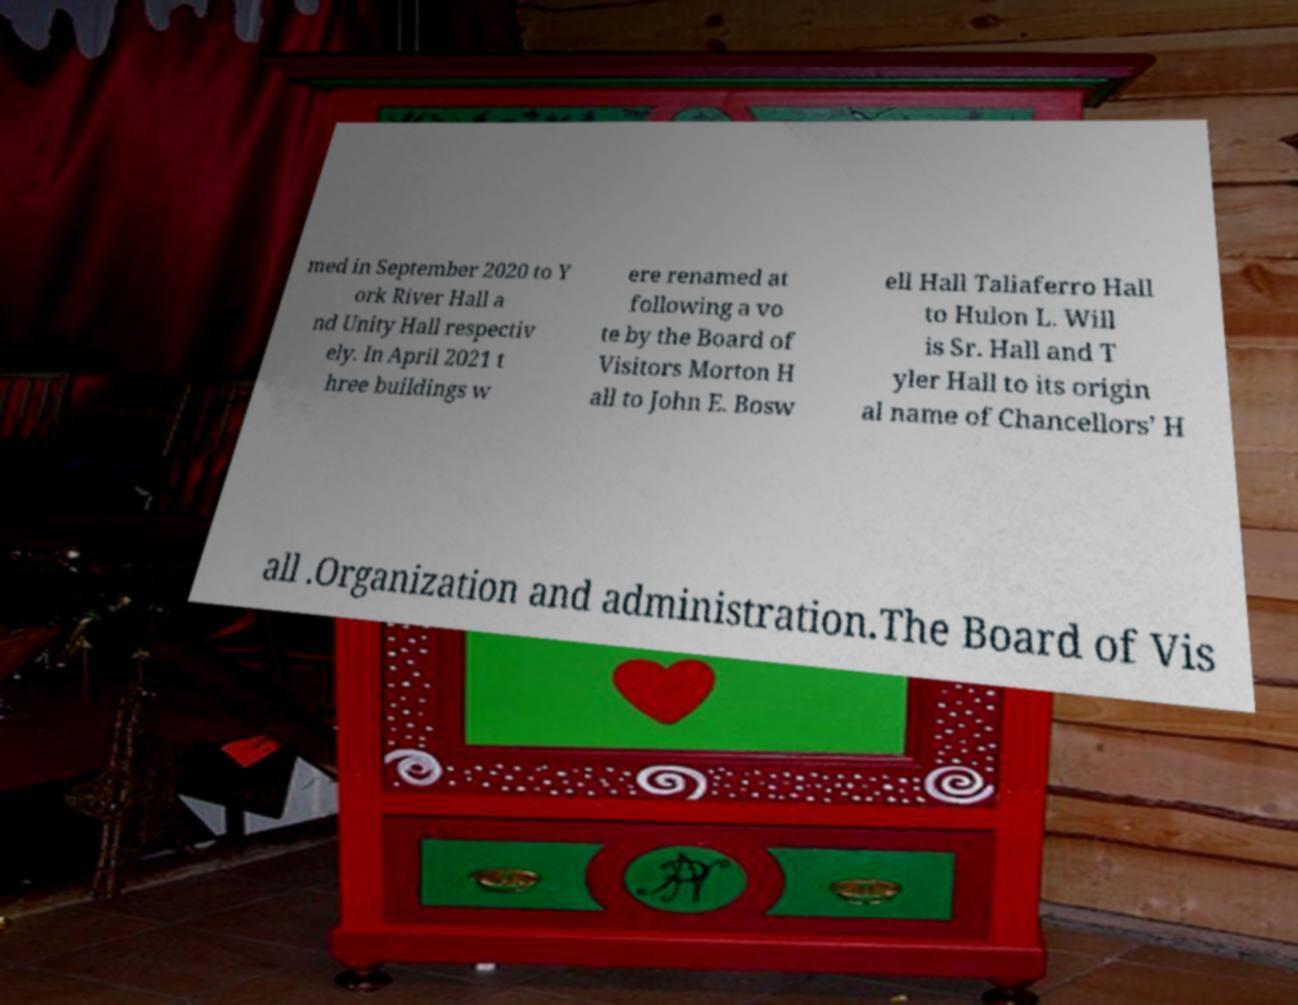For documentation purposes, I need the text within this image transcribed. Could you provide that? med in September 2020 to Y ork River Hall a nd Unity Hall respectiv ely. In April 2021 t hree buildings w ere renamed at following a vo te by the Board of Visitors Morton H all to John E. Bosw ell Hall Taliaferro Hall to Hulon L. Will is Sr. Hall and T yler Hall to its origin al name of Chancellors’ H all .Organization and administration.The Board of Vis 